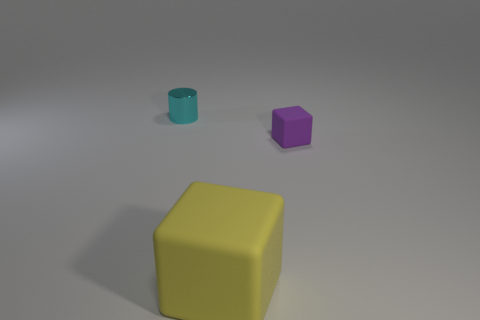Is there any other thing that has the same shape as the small cyan object?
Ensure brevity in your answer.  No. Are there any other things that have the same size as the yellow object?
Offer a very short reply. No. Are there any small purple things of the same shape as the yellow object?
Give a very brief answer. Yes. How many other objects are there of the same color as the big cube?
Offer a terse response. 0. What color is the tiny object in front of the tiny object that is behind the tiny thing that is on the right side of the large matte thing?
Make the answer very short. Purple. Are there an equal number of yellow objects that are behind the cyan object and small shiny things?
Make the answer very short. No. There is a cube in front of the purple matte thing; does it have the same size as the purple thing?
Offer a very short reply. No. What number of small things are there?
Your answer should be compact. 2. What number of objects are behind the small purple rubber block and in front of the cyan thing?
Provide a short and direct response. 0. Are there any small purple cubes that have the same material as the large yellow block?
Make the answer very short. Yes. 